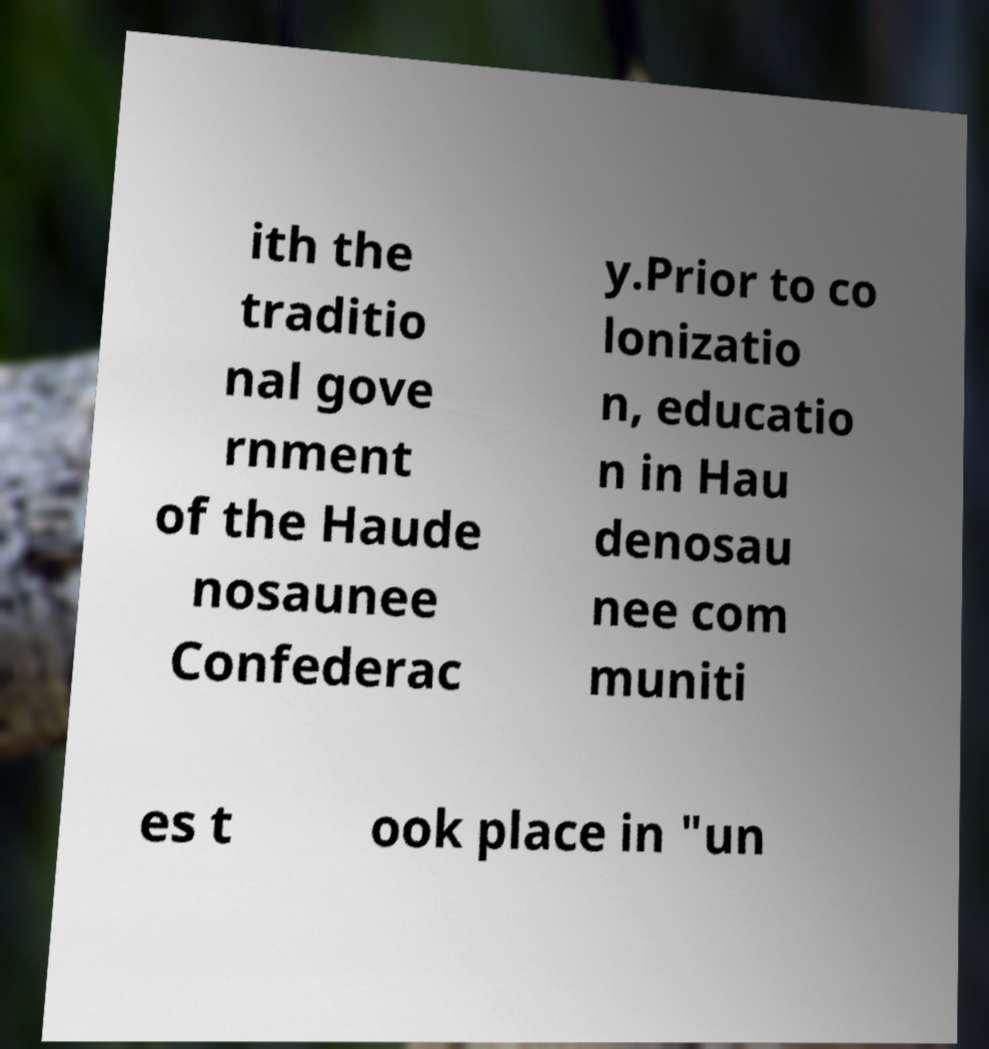I need the written content from this picture converted into text. Can you do that? ith the traditio nal gove rnment of the Haude nosaunee Confederac y.Prior to co lonizatio n, educatio n in Hau denosau nee com muniti es t ook place in "un 